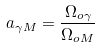Convert formula to latex. <formula><loc_0><loc_0><loc_500><loc_500>a _ { \gamma M } = \frac { \Omega _ { o \gamma } } { \Omega _ { o M } }</formula> 